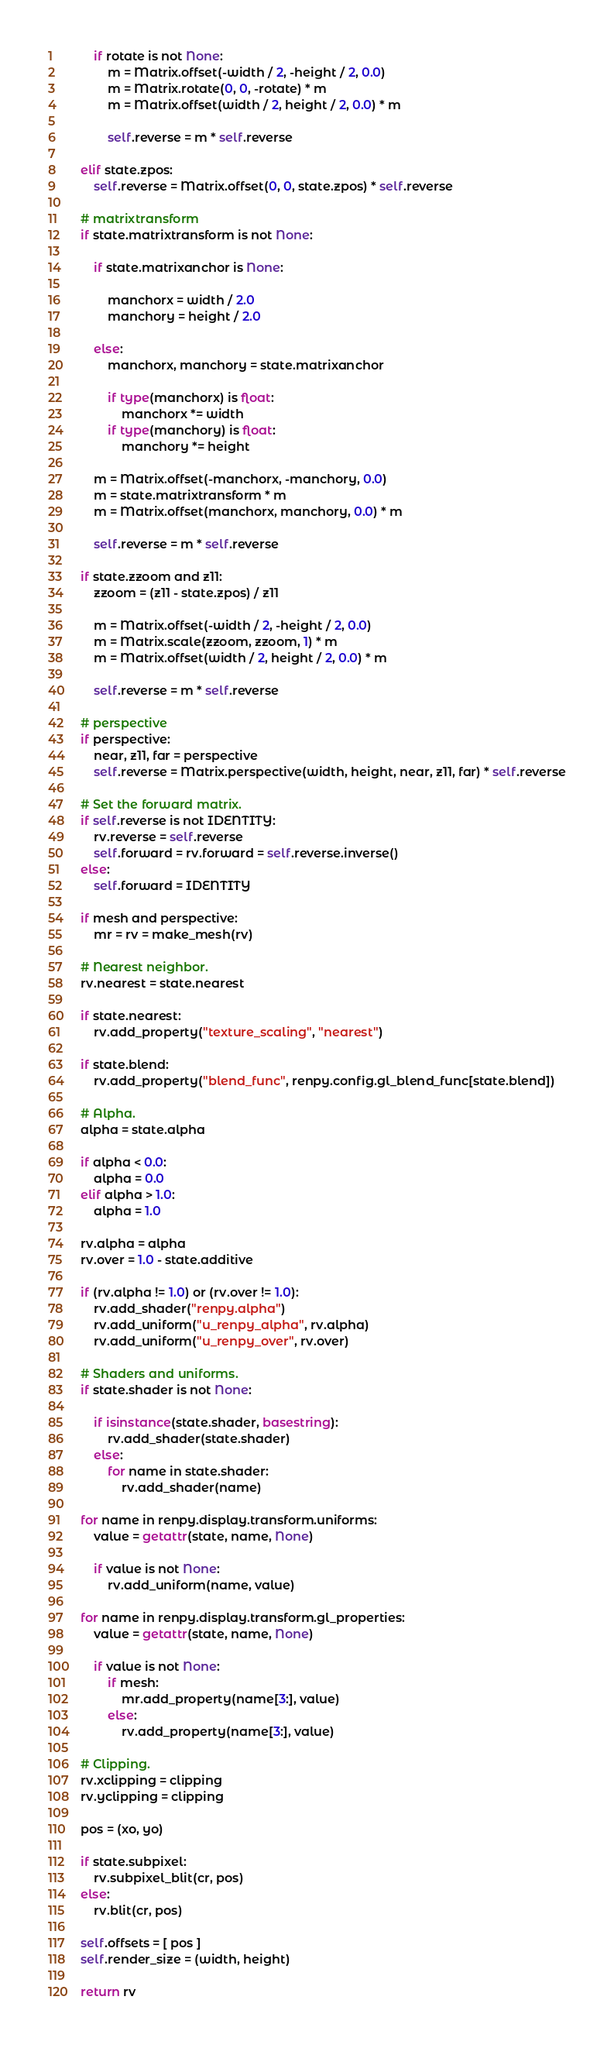<code> <loc_0><loc_0><loc_500><loc_500><_Cython_>
        if rotate is not None:
            m = Matrix.offset(-width / 2, -height / 2, 0.0)
            m = Matrix.rotate(0, 0, -rotate) * m
            m = Matrix.offset(width / 2, height / 2, 0.0) * m

            self.reverse = m * self.reverse

    elif state.zpos:
        self.reverse = Matrix.offset(0, 0, state.zpos) * self.reverse

    # matrixtransform
    if state.matrixtransform is not None:

        if state.matrixanchor is None:

            manchorx = width / 2.0
            manchory = height / 2.0

        else:
            manchorx, manchory = state.matrixanchor

            if type(manchorx) is float:
                manchorx *= width
            if type(manchory) is float:
                manchory *= height

        m = Matrix.offset(-manchorx, -manchory, 0.0)
        m = state.matrixtransform * m
        m = Matrix.offset(manchorx, manchory, 0.0) * m

        self.reverse = m * self.reverse

    if state.zzoom and z11:
        zzoom = (z11 - state.zpos) / z11

        m = Matrix.offset(-width / 2, -height / 2, 0.0)
        m = Matrix.scale(zzoom, zzoom, 1) * m
        m = Matrix.offset(width / 2, height / 2, 0.0) * m

        self.reverse = m * self.reverse

    # perspective
    if perspective:
        near, z11, far = perspective
        self.reverse = Matrix.perspective(width, height, near, z11, far) * self.reverse

    # Set the forward matrix.
    if self.reverse is not IDENTITY:
        rv.reverse = self.reverse
        self.forward = rv.forward = self.reverse.inverse()
    else:
        self.forward = IDENTITY

    if mesh and perspective:
        mr = rv = make_mesh(rv)

    # Nearest neighbor.
    rv.nearest = state.nearest

    if state.nearest:
        rv.add_property("texture_scaling", "nearest")

    if state.blend:
        rv.add_property("blend_func", renpy.config.gl_blend_func[state.blend])

    # Alpha.
    alpha = state.alpha

    if alpha < 0.0:
        alpha = 0.0
    elif alpha > 1.0:
        alpha = 1.0

    rv.alpha = alpha
    rv.over = 1.0 - state.additive

    if (rv.alpha != 1.0) or (rv.over != 1.0):
        rv.add_shader("renpy.alpha")
        rv.add_uniform("u_renpy_alpha", rv.alpha)
        rv.add_uniform("u_renpy_over", rv.over)

    # Shaders and uniforms.
    if state.shader is not None:

        if isinstance(state.shader, basestring):
            rv.add_shader(state.shader)
        else:
            for name in state.shader:
                rv.add_shader(name)

    for name in renpy.display.transform.uniforms:
        value = getattr(state, name, None)

        if value is not None:
            rv.add_uniform(name, value)

    for name in renpy.display.transform.gl_properties:
        value = getattr(state, name, None)

        if value is not None:
            if mesh:
                mr.add_property(name[3:], value)
            else:
                rv.add_property(name[3:], value)

    # Clipping.
    rv.xclipping = clipping
    rv.yclipping = clipping

    pos = (xo, yo)

    if state.subpixel:
        rv.subpixel_blit(cr, pos)
    else:
        rv.blit(cr, pos)

    self.offsets = [ pos ]
    self.render_size = (width, height)

    return rv
</code> 